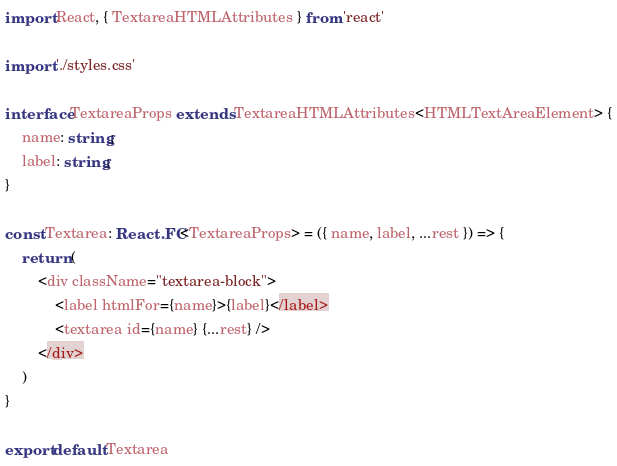Convert code to text. <code><loc_0><loc_0><loc_500><loc_500><_TypeScript_>import React, { TextareaHTMLAttributes } from 'react'

import './styles.css'

interface TextareaProps extends TextareaHTMLAttributes<HTMLTextAreaElement> {
    name: string;
    label: string;
}

const Textarea: React.FC<TextareaProps> = ({ name, label, ...rest }) => {
    return (
        <div className="textarea-block">
            <label htmlFor={name}>{label}</label>
            <textarea id={name} {...rest} />
        </div>
    )
}

export default Textarea</code> 